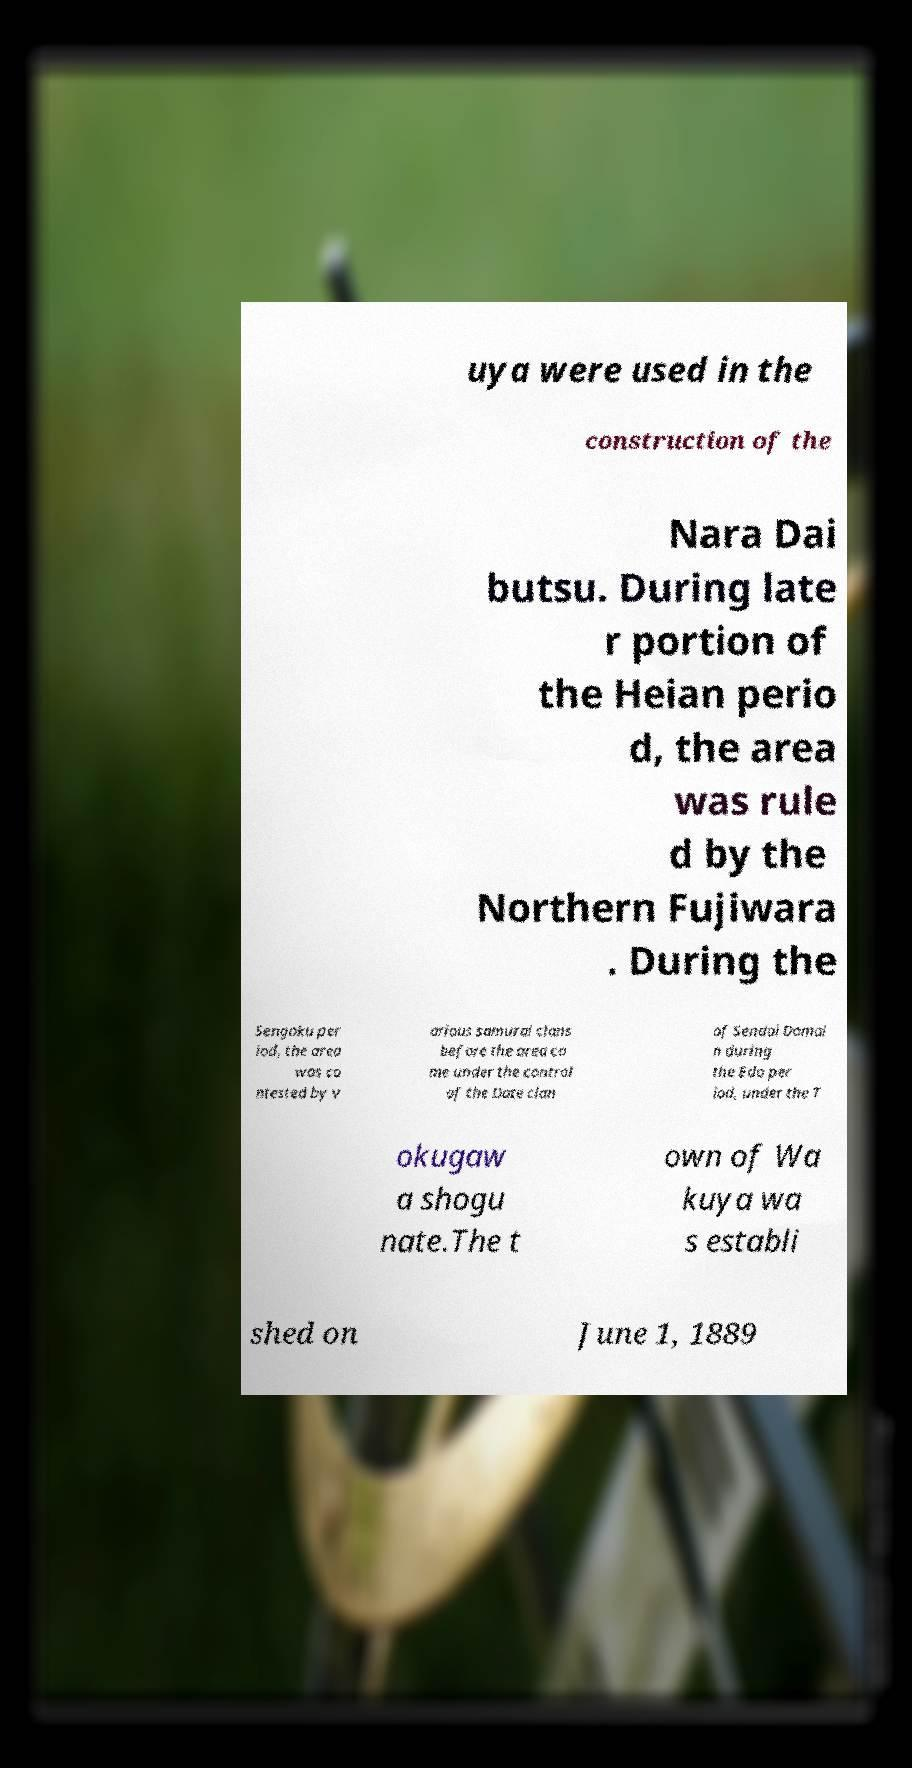I need the written content from this picture converted into text. Can you do that? uya were used in the construction of the Nara Dai butsu. During late r portion of the Heian perio d, the area was rule d by the Northern Fujiwara . During the Sengoku per iod, the area was co ntested by v arious samurai clans before the area ca me under the control of the Date clan of Sendai Domai n during the Edo per iod, under the T okugaw a shogu nate.The t own of Wa kuya wa s establi shed on June 1, 1889 